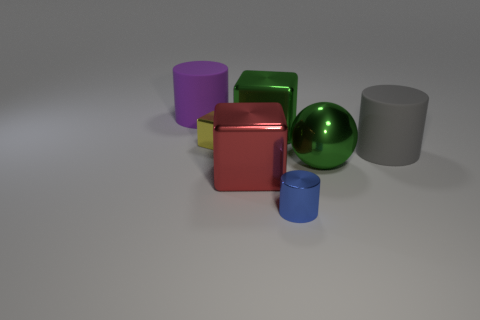Subtract all red shiny cubes. How many cubes are left? 2 Add 1 tiny yellow rubber balls. How many objects exist? 8 Subtract all spheres. How many objects are left? 6 Subtract all gray cubes. Subtract all brown cylinders. How many cubes are left? 3 Add 3 small yellow shiny things. How many small yellow shiny things exist? 4 Subtract 0 brown spheres. How many objects are left? 7 Subtract all shiny balls. Subtract all yellow blocks. How many objects are left? 5 Add 4 rubber cylinders. How many rubber cylinders are left? 6 